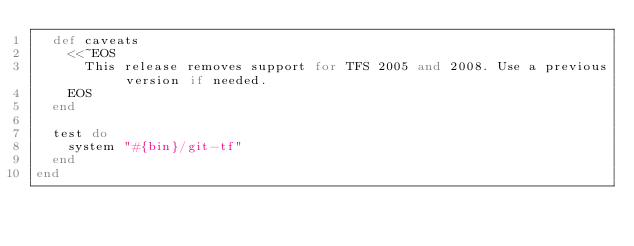Convert code to text. <code><loc_0><loc_0><loc_500><loc_500><_Ruby_>  def caveats
    <<~EOS
      This release removes support for TFS 2005 and 2008. Use a previous version if needed.
    EOS
  end

  test do
    system "#{bin}/git-tf"
  end
end
</code> 